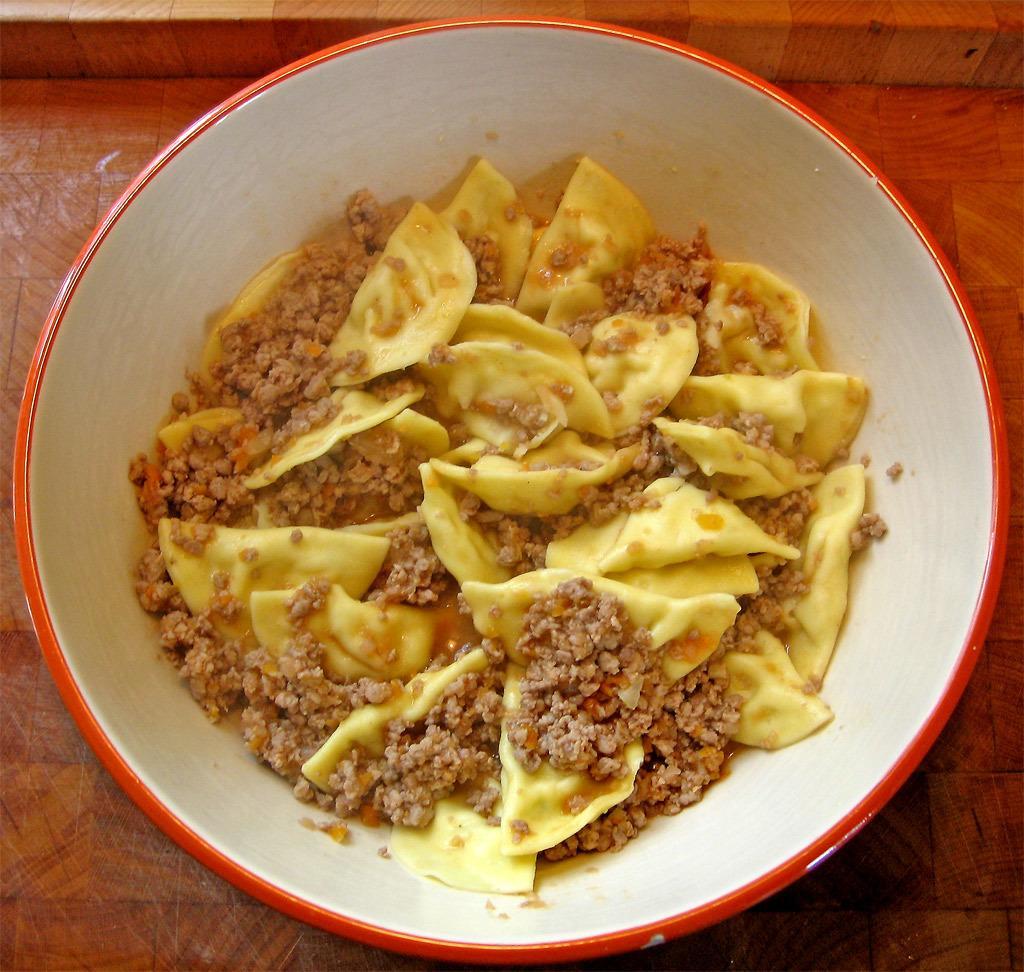Could you give a brief overview of what you see in this image? In this picture we can see a bowl, there is some food present in this bowl, at the bottom there is wooden surface. 